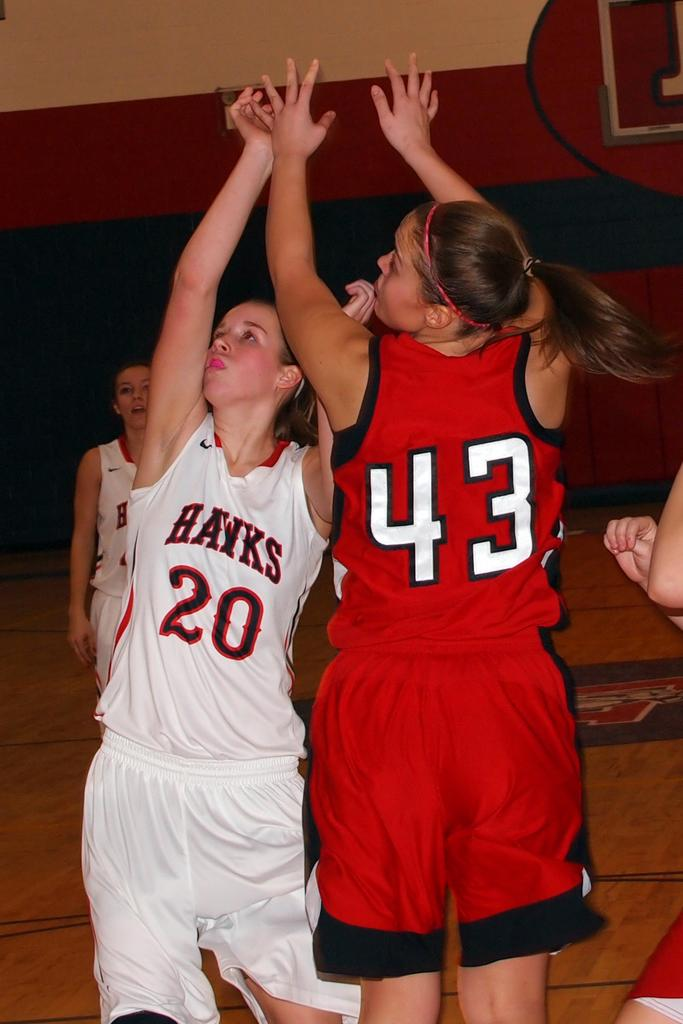<image>
Describe the image concisely. Number 20 and number 43 players are going against each other to get the basketball. 